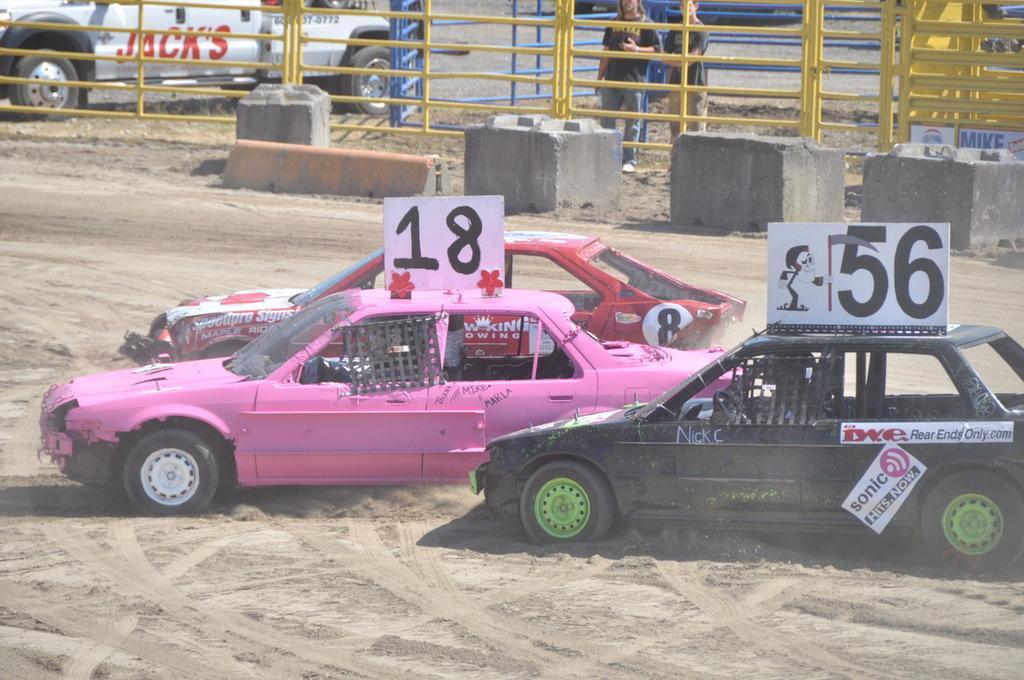Can you describe this image briefly? In the image we can see there are vehicles of different colors. Here we can see sand, fence and there are two people standing, wearing clothes. Here we can see the board and the text. 